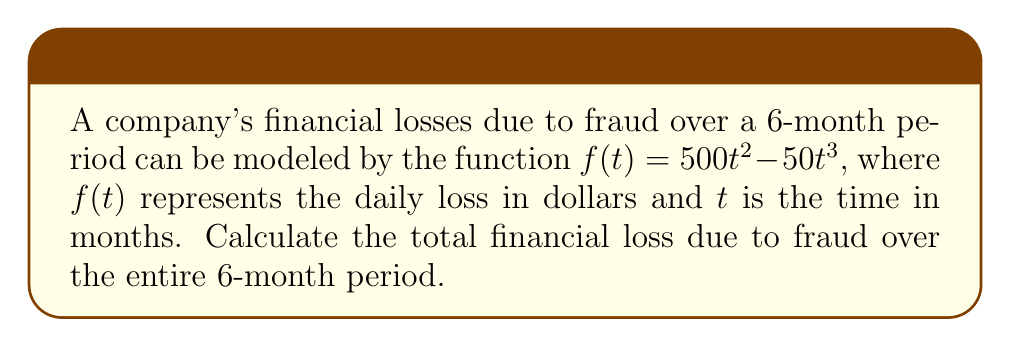Give your solution to this math problem. To solve this problem, we need to find the area under the curve of $f(t)$ from $t=0$ to $t=6$. This can be done using definite integration.

1. Set up the definite integral:
   $$\int_0^6 (500t^2 - 50t^3) dt$$

2. Integrate the function:
   $$\left[\frac{500t^3}{3} - \frac{50t^4}{4}\right]_0^6$$

3. Evaluate the integral at the upper and lower bounds:
   $$\left(\frac{500(6^3)}{3} - \frac{50(6^4)}{4}\right) - \left(\frac{500(0^3)}{3} - \frac{50(0^4)}{4}\right)$$

4. Simplify:
   $$\left(36000 - 32400\right) - (0 - 0) = 3600$$

Therefore, the total financial loss due to fraud over the 6-month period is $3,600.
Answer: $3,600 